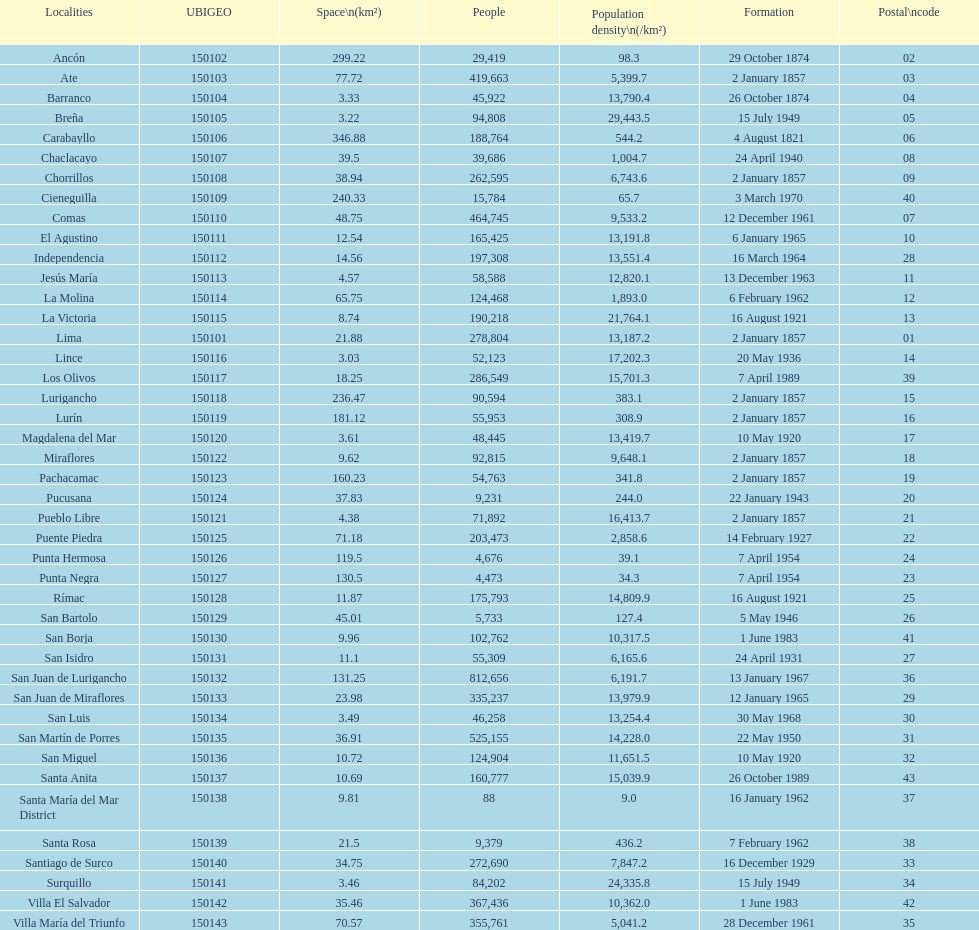Which district in this city has the greatest population? San Juan de Lurigancho. 